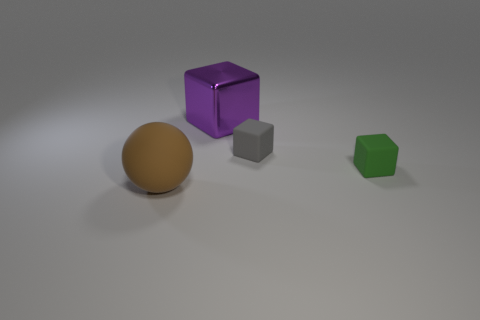Is there anything else that is made of the same material as the purple thing?
Keep it short and to the point. No. There is a big thing that is behind the rubber thing that is on the left side of the big shiny block; what number of tiny green rubber things are on the right side of it?
Give a very brief answer. 1. Is the shape of the object that is behind the gray matte object the same as  the gray thing?
Keep it short and to the point. Yes. What number of things are purple shiny cubes or blocks that are left of the tiny gray matte block?
Offer a very short reply. 1. Is the number of green things right of the gray thing greater than the number of small shiny cylinders?
Your answer should be very brief. Yes. Are there the same number of cubes right of the green rubber thing and big purple metallic cubes behind the large shiny object?
Make the answer very short. Yes. There is a matte block in front of the gray cube; is there a thing that is to the left of it?
Offer a terse response. Yes. What shape is the big rubber object?
Your response must be concise. Sphere. There is a cube that is on the left side of the tiny cube to the left of the small green matte object; how big is it?
Ensure brevity in your answer.  Large. What is the size of the matte object that is to the left of the purple shiny object?
Provide a succinct answer. Large. 